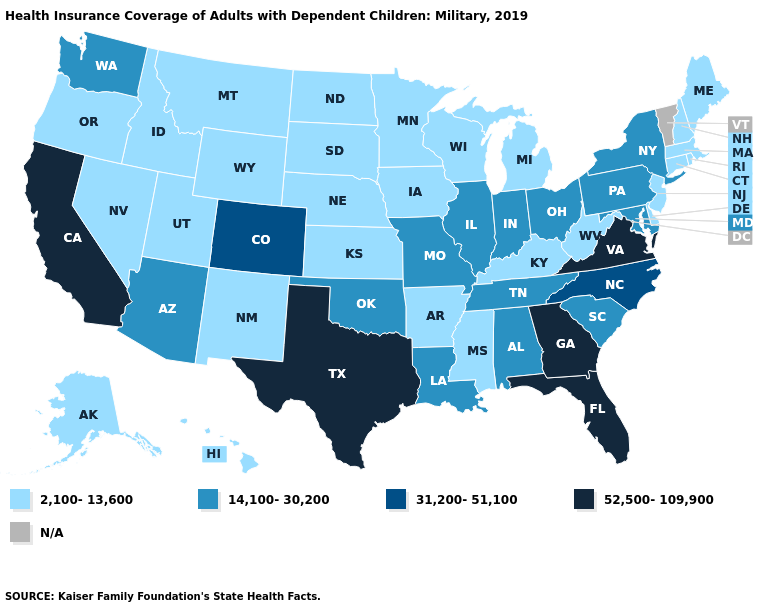Does New Mexico have the lowest value in the West?
Answer briefly. Yes. Does the first symbol in the legend represent the smallest category?
Give a very brief answer. Yes. Name the states that have a value in the range 14,100-30,200?
Keep it brief. Alabama, Arizona, Illinois, Indiana, Louisiana, Maryland, Missouri, New York, Ohio, Oklahoma, Pennsylvania, South Carolina, Tennessee, Washington. Which states have the lowest value in the USA?
Keep it brief. Alaska, Arkansas, Connecticut, Delaware, Hawaii, Idaho, Iowa, Kansas, Kentucky, Maine, Massachusetts, Michigan, Minnesota, Mississippi, Montana, Nebraska, Nevada, New Hampshire, New Jersey, New Mexico, North Dakota, Oregon, Rhode Island, South Dakota, Utah, West Virginia, Wisconsin, Wyoming. Name the states that have a value in the range 31,200-51,100?
Quick response, please. Colorado, North Carolina. Which states have the lowest value in the West?
Give a very brief answer. Alaska, Hawaii, Idaho, Montana, Nevada, New Mexico, Oregon, Utah, Wyoming. Name the states that have a value in the range 14,100-30,200?
Answer briefly. Alabama, Arizona, Illinois, Indiana, Louisiana, Maryland, Missouri, New York, Ohio, Oklahoma, Pennsylvania, South Carolina, Tennessee, Washington. Name the states that have a value in the range 52,500-109,900?
Keep it brief. California, Florida, Georgia, Texas, Virginia. Name the states that have a value in the range N/A?
Answer briefly. Vermont. What is the value of New Hampshire?
Be succinct. 2,100-13,600. Among the states that border New York , which have the highest value?
Short answer required. Pennsylvania. What is the value of Kansas?
Quick response, please. 2,100-13,600. What is the value of Illinois?
Keep it brief. 14,100-30,200. 